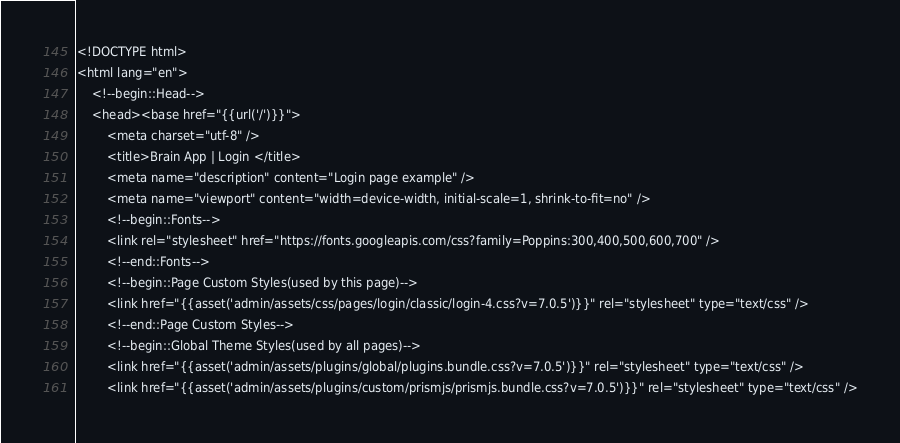Convert code to text. <code><loc_0><loc_0><loc_500><loc_500><_PHP_><!DOCTYPE html>
<html lang="en">
    <!--begin::Head-->
    <head><base href="{{url('/')}}">
        <meta charset="utf-8" />
        <title>Brain App | Login </title>
        <meta name="description" content="Login page example" />
        <meta name="viewport" content="width=device-width, initial-scale=1, shrink-to-fit=no" />
        <!--begin::Fonts-->
        <link rel="stylesheet" href="https://fonts.googleapis.com/css?family=Poppins:300,400,500,600,700" />
        <!--end::Fonts-->
        <!--begin::Page Custom Styles(used by this page)-->
        <link href="{{asset('admin/assets/css/pages/login/classic/login-4.css?v=7.0.5')}}" rel="stylesheet" type="text/css" />
        <!--end::Page Custom Styles-->
        <!--begin::Global Theme Styles(used by all pages)-->
        <link href="{{asset('admin/assets/plugins/global/plugins.bundle.css?v=7.0.5')}}" rel="stylesheet" type="text/css" />
        <link href="{{asset('admin/assets/plugins/custom/prismjs/prismjs.bundle.css?v=7.0.5')}}" rel="stylesheet" type="text/css" /></code> 